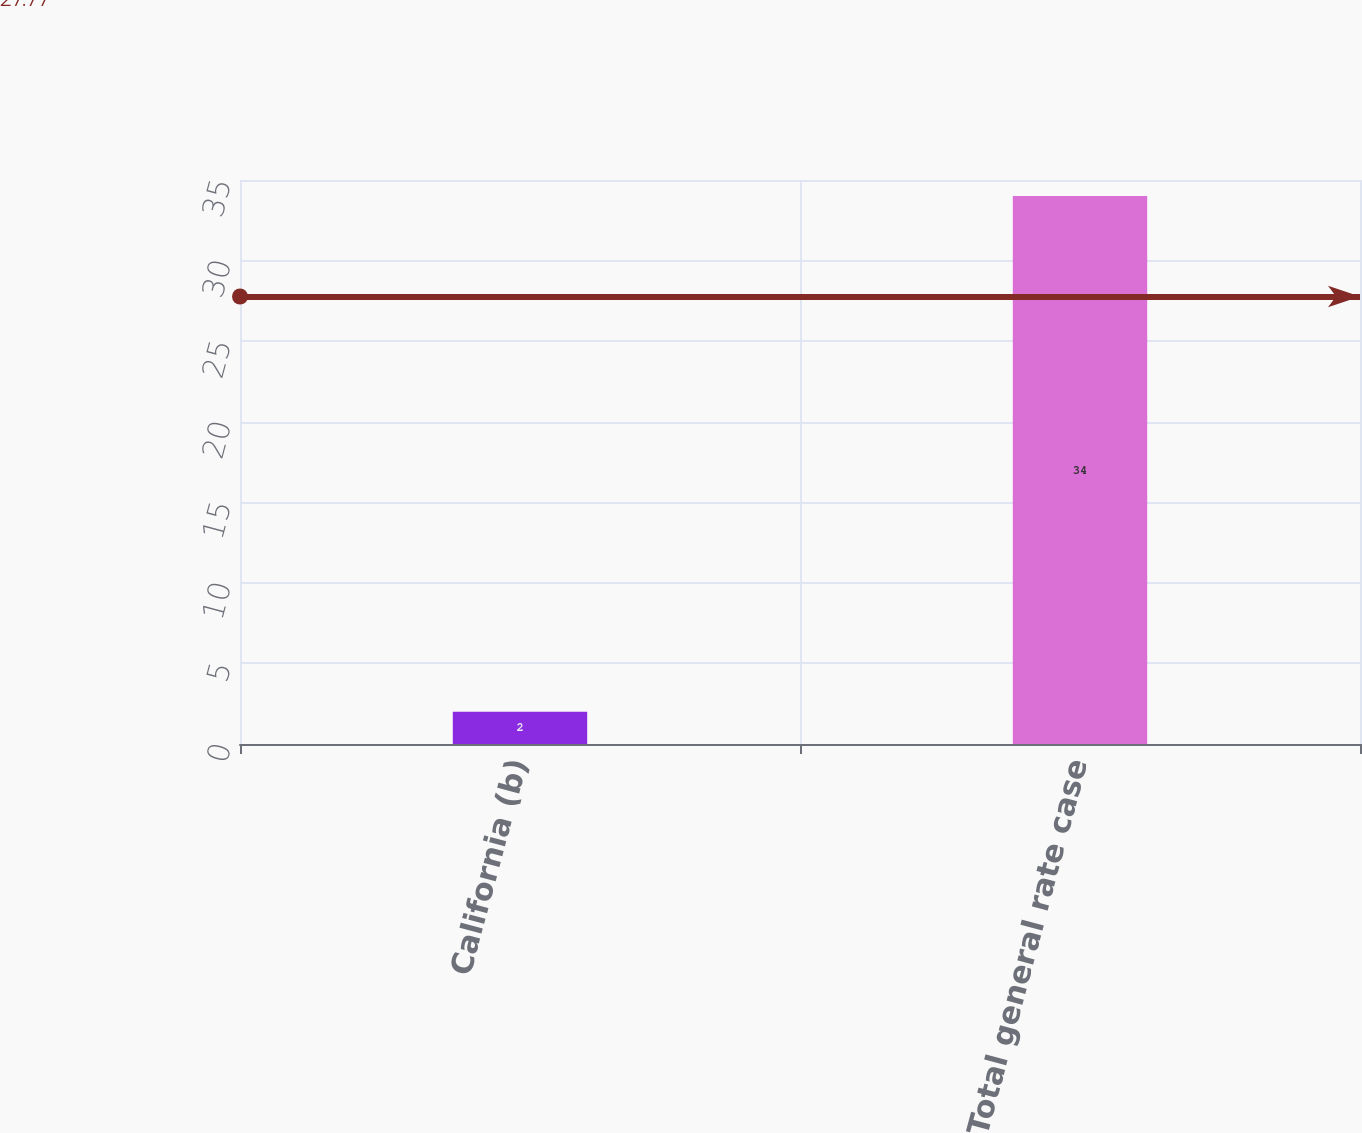Convert chart. <chart><loc_0><loc_0><loc_500><loc_500><bar_chart><fcel>California (b)<fcel>Total general rate case<nl><fcel>2<fcel>34<nl></chart> 